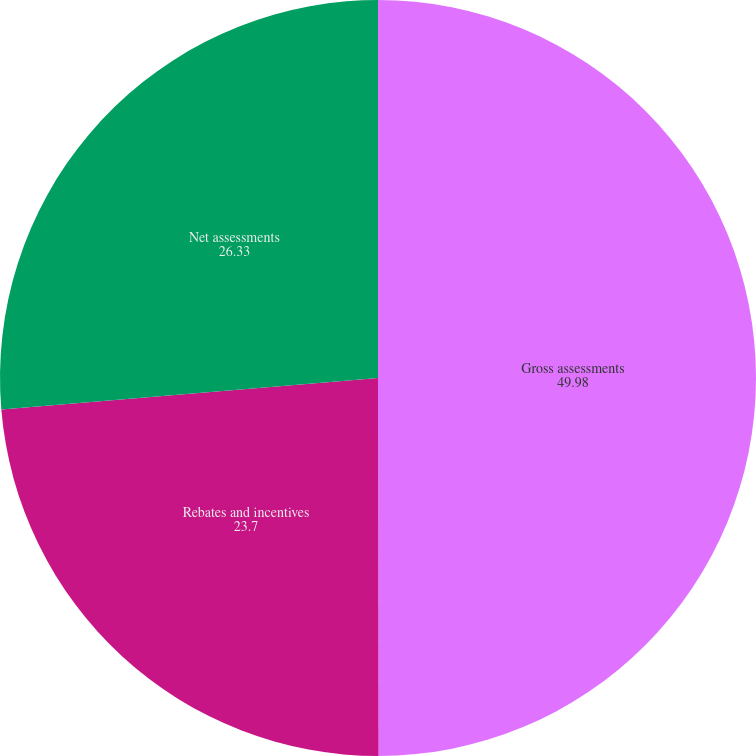Convert chart to OTSL. <chart><loc_0><loc_0><loc_500><loc_500><pie_chart><fcel>Gross assessments<fcel>Rebates and incentives<fcel>Net assessments<nl><fcel>49.98%<fcel>23.7%<fcel>26.33%<nl></chart> 